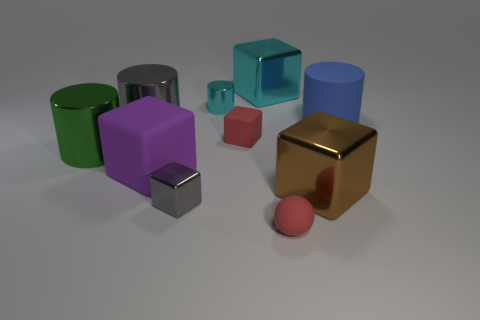Is the color of the tiny matte cube the same as the tiny matte ball? Yes, both the tiny matte cube and the tiny matte ball share the same shade of red, indicating that they are of the same color. 